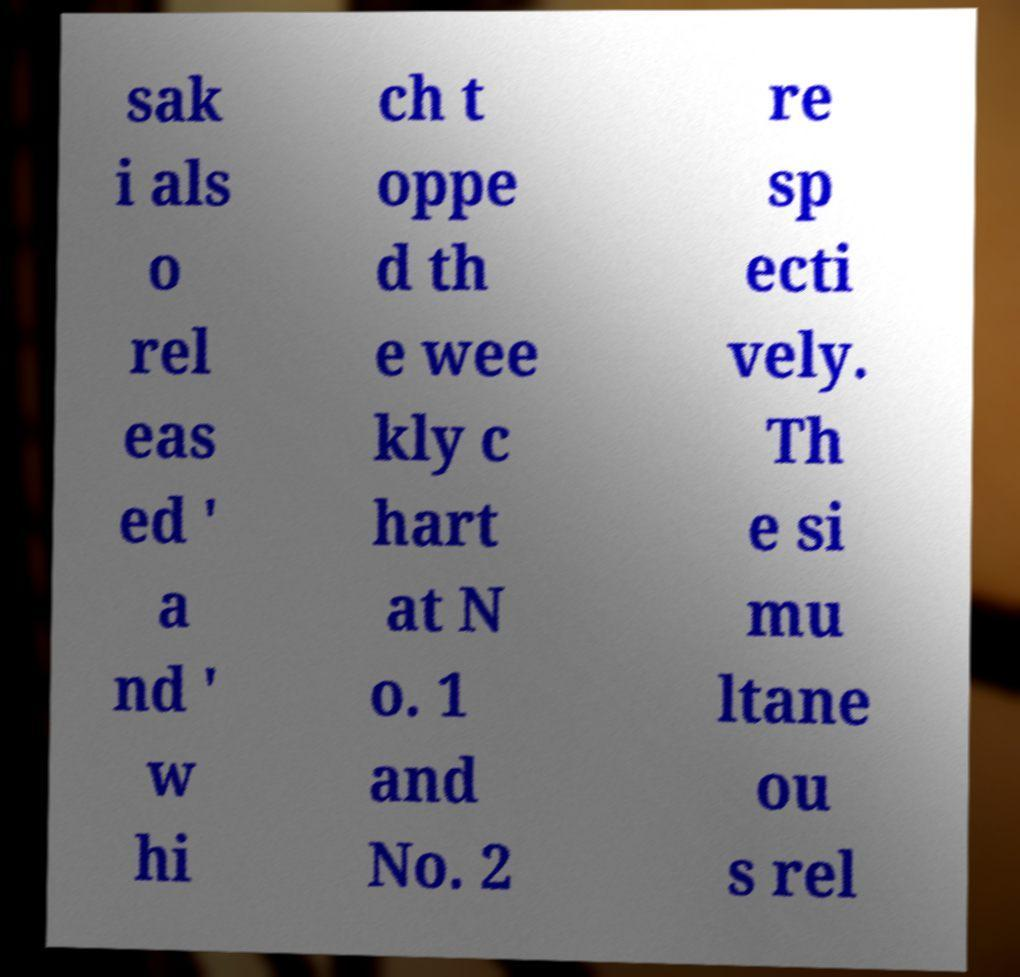I need the written content from this picture converted into text. Can you do that? sak i als o rel eas ed ' a nd ' w hi ch t oppe d th e wee kly c hart at N o. 1 and No. 2 re sp ecti vely. Th e si mu ltane ou s rel 